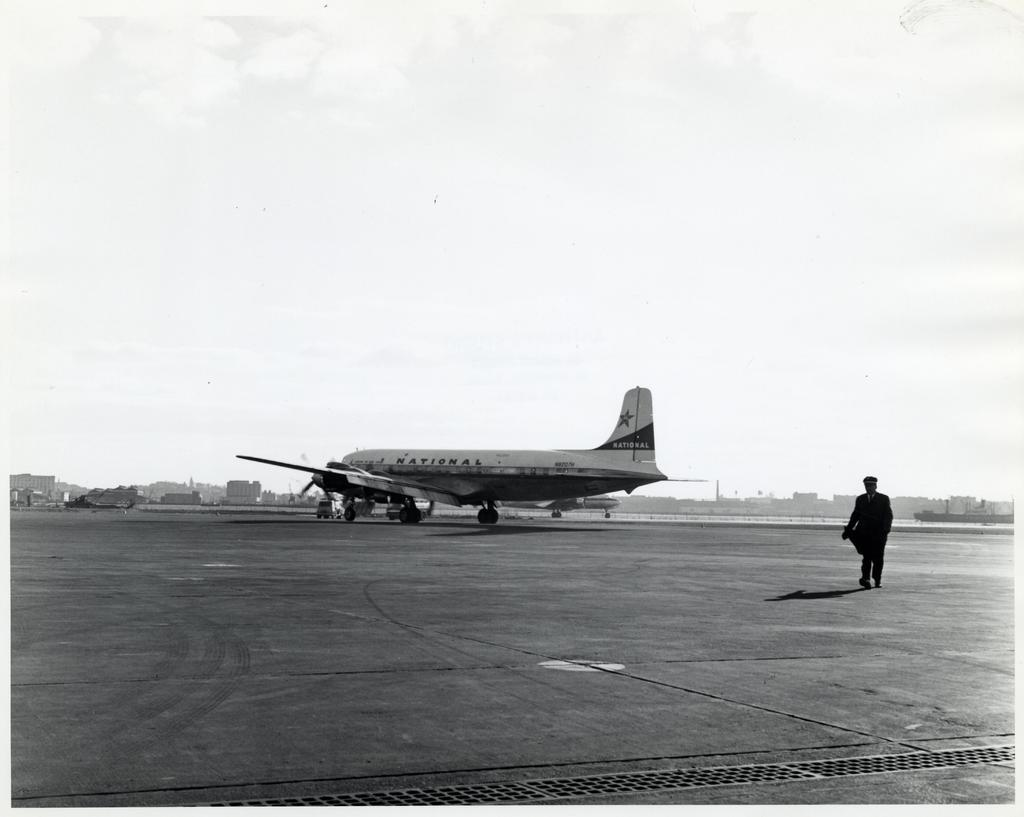What is the color scheme of the image? The image is black and white. What is the main subject of the image? There is an airplane in the image. Can you describe the person on the right side of the image? There is a person on the right side of the image. What can be seen in the background of the image? The sky is visible in the background of the image. How many beds are visible in the image? There are no beds present in the image. What type of humor is being displayed by the person in the image? There is no indication of humor in the image; it simply shows a person and an airplane. 